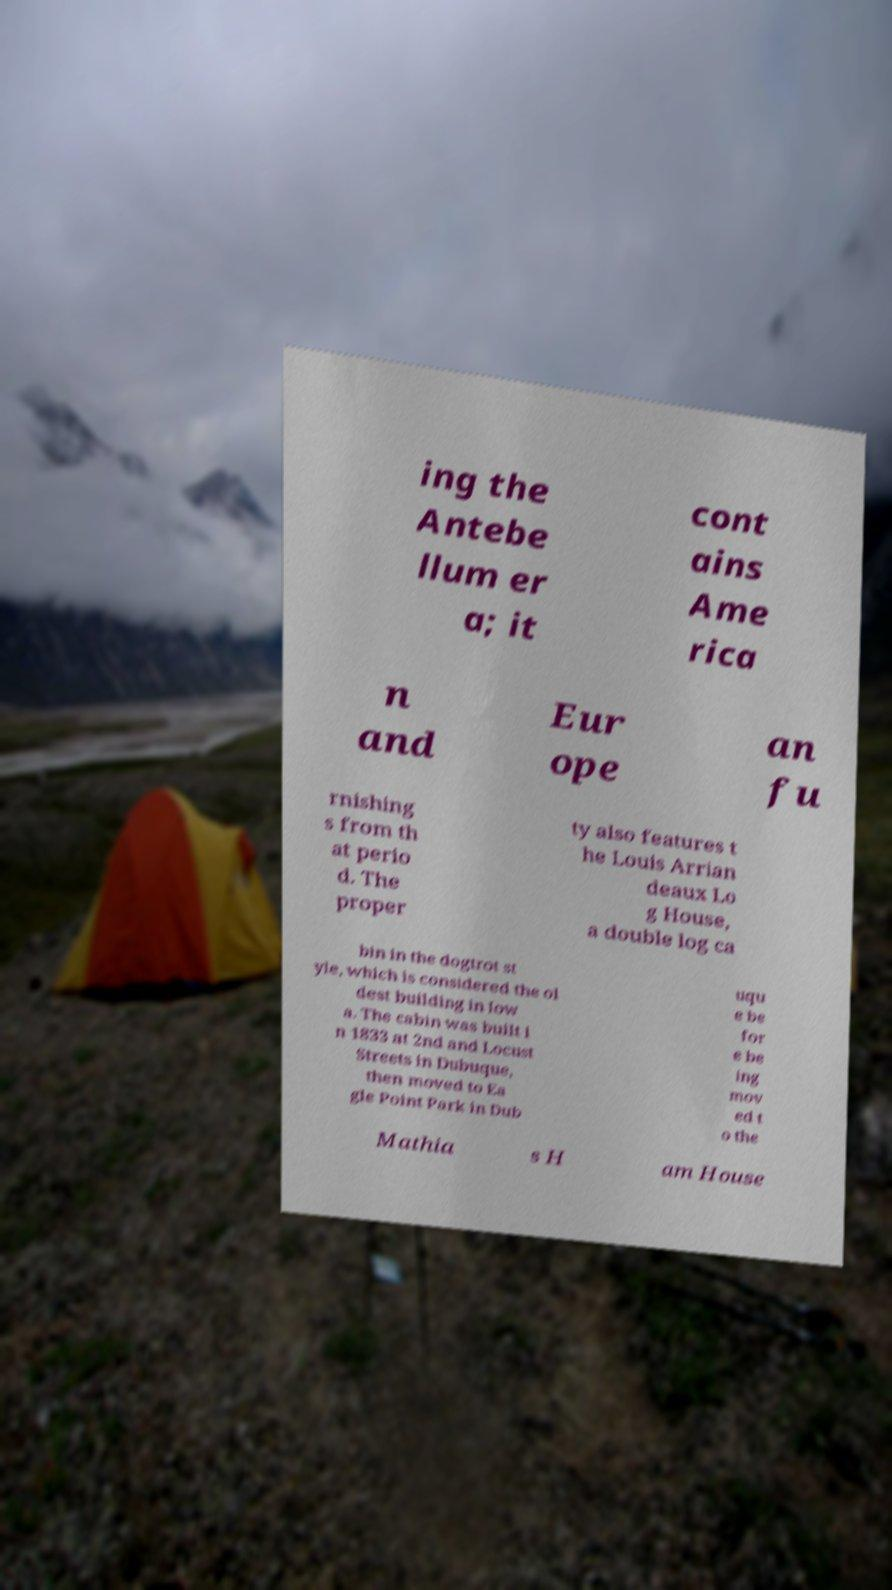For documentation purposes, I need the text within this image transcribed. Could you provide that? ing the Antebe llum er a; it cont ains Ame rica n and Eur ope an fu rnishing s from th at perio d. The proper ty also features t he Louis Arrian deaux Lo g House, a double log ca bin in the dogtrot st yle, which is considered the ol dest building in Iow a. The cabin was built i n 1833 at 2nd and Locust Streets in Dubuque, then moved to Ea gle Point Park in Dub uqu e be for e be ing mov ed t o the Mathia s H am House 